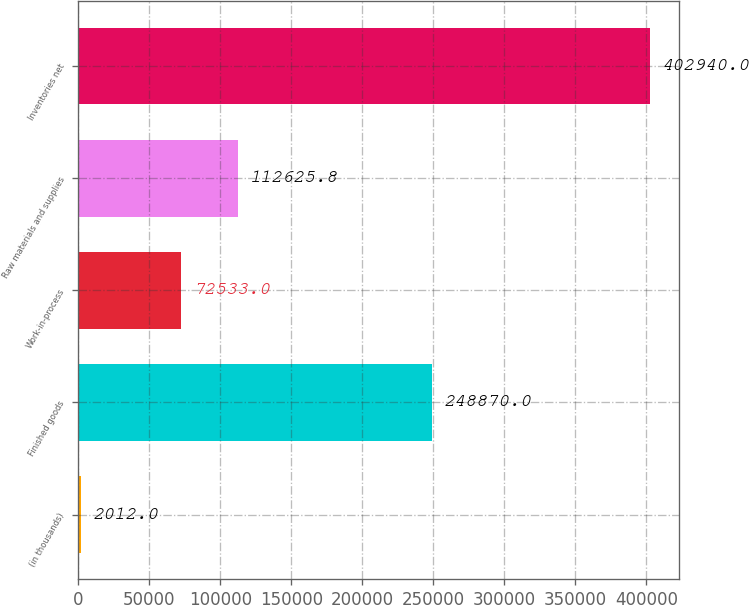Convert chart to OTSL. <chart><loc_0><loc_0><loc_500><loc_500><bar_chart><fcel>(in thousands)<fcel>Finished goods<fcel>Work-in-process<fcel>Raw materials and supplies<fcel>Inventories net<nl><fcel>2012<fcel>248870<fcel>72533<fcel>112626<fcel>402940<nl></chart> 